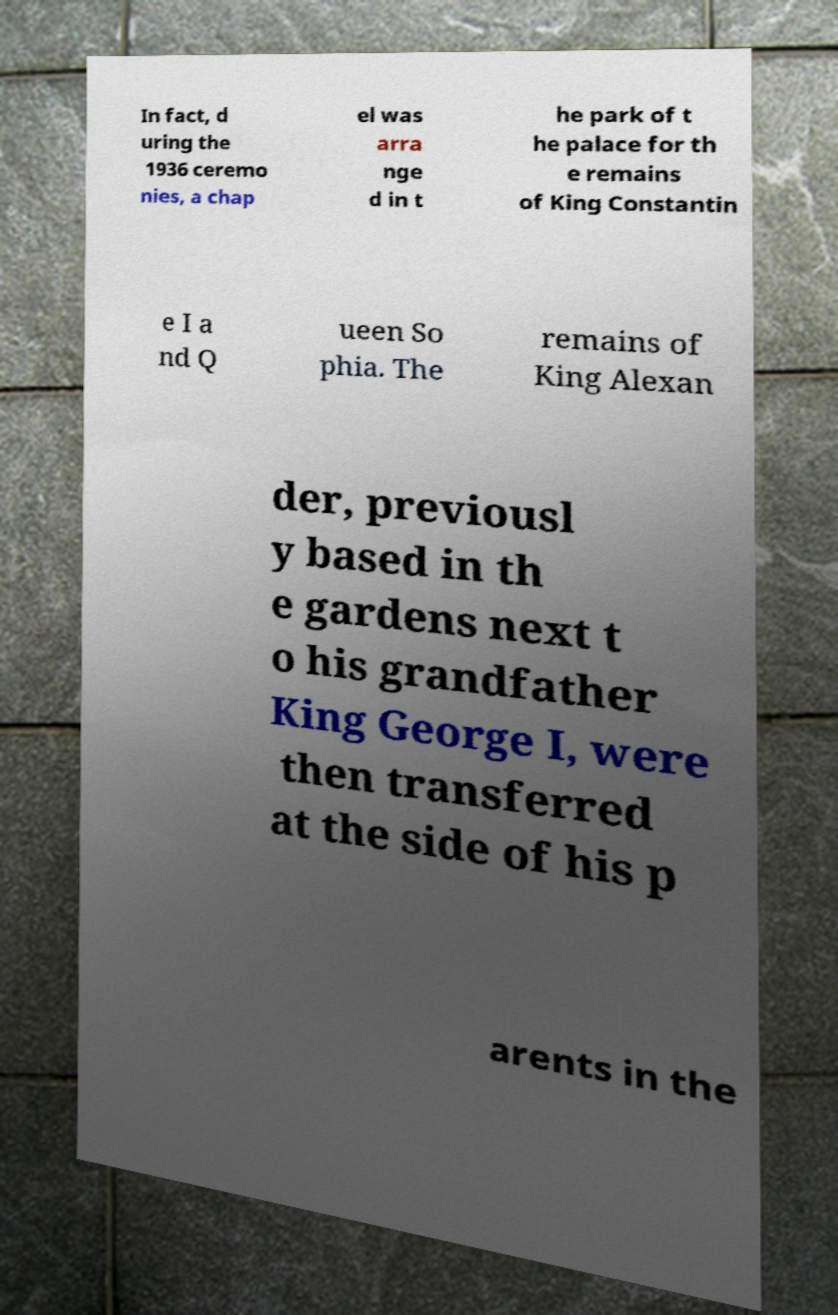What messages or text are displayed in this image? I need them in a readable, typed format. In fact, d uring the 1936 ceremo nies, a chap el was arra nge d in t he park of t he palace for th e remains of King Constantin e I a nd Q ueen So phia. The remains of King Alexan der, previousl y based in th e gardens next t o his grandfather King George I, were then transferred at the side of his p arents in the 